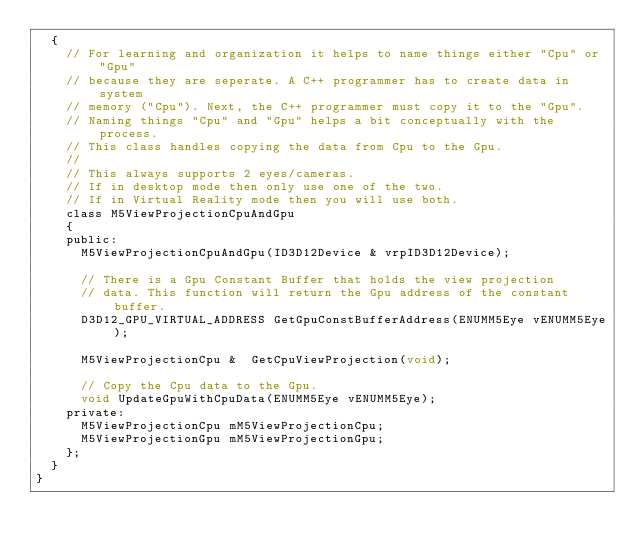<code> <loc_0><loc_0><loc_500><loc_500><_C_>	{
		// For learning and organization it helps to name things either "Cpu" or "Gpu" 
		// because they are seperate. A C++ programmer has to create data in system 
		// memory ("Cpu"). Next, the C++ programmer must copy it to the "Gpu". 
		// Naming things "Cpu" and "Gpu" helps a bit conceptually with the process.
		// This class handles copying the data from Cpu to the Gpu.
		//
		// This always supports 2 eyes/cameras. 
		// If in desktop mode then only use one of the two.
		// If in Virtual Reality mode then you will use both.
		class M5ViewProjectionCpuAndGpu
		{
		public:
			M5ViewProjectionCpuAndGpu(ID3D12Device & vrpID3D12Device);

			// There is a Gpu Constant Buffer that holds the view projection 
			// data. This function will return the Gpu address of the constant buffer.
			D3D12_GPU_VIRTUAL_ADDRESS GetGpuConstBufferAddress(ENUMM5Eye vENUMM5Eye);

			M5ViewProjectionCpu &  GetCpuViewProjection(void);

			// Copy the Cpu data to the Gpu.
			void UpdateGpuWithCpuData(ENUMM5Eye vENUMM5Eye);
		private:
			M5ViewProjectionCpu mM5ViewProjectionCpu;
			M5ViewProjectionGpu mM5ViewProjectionGpu;
		};
	}
}</code> 